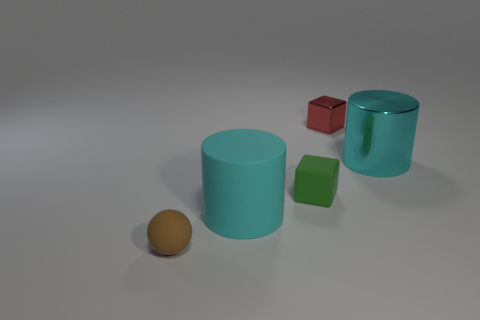Add 2 green matte blocks. How many objects exist? 7 Subtract all cylinders. How many objects are left? 3 Subtract 1 brown balls. How many objects are left? 4 Subtract all matte objects. Subtract all large matte objects. How many objects are left? 1 Add 2 brown matte things. How many brown matte things are left? 3 Add 3 red blocks. How many red blocks exist? 4 